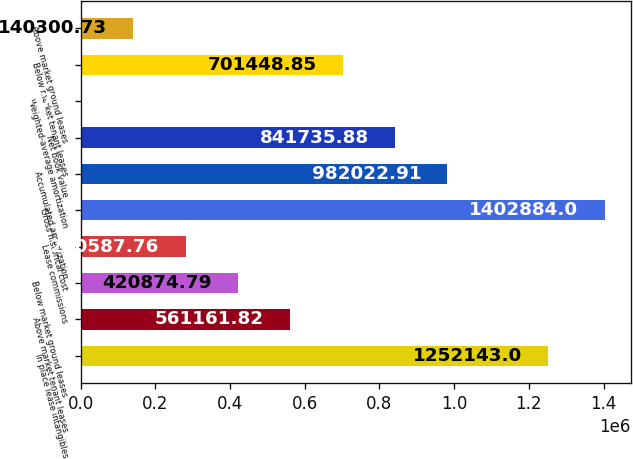<chart> <loc_0><loc_0><loc_500><loc_500><bar_chart><fcel>In place lease intangibles<fcel>Above market tenant leases<fcel>Below market ground leases<fcel>Lease commissions<fcel>Gross historical cost<fcel>Accumulated amortization<fcel>Net book value<fcel>Weighted-average amortization<fcel>Below market tenant leases<fcel>Above market ground leases<nl><fcel>1.25214e+06<fcel>561162<fcel>420875<fcel>280588<fcel>1.40288e+06<fcel>982023<fcel>841736<fcel>13.7<fcel>701449<fcel>140301<nl></chart> 